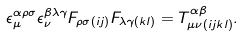<formula> <loc_0><loc_0><loc_500><loc_500>\epsilon _ { \mu } ^ { \alpha \rho \sigma } \epsilon _ { \nu } ^ { \beta \lambda \gamma } F _ { \rho \sigma ( i j ) } F _ { \lambda \gamma ( k l ) } = T _ { \mu \nu ( i j k l ) } ^ { \alpha \beta } .</formula> 